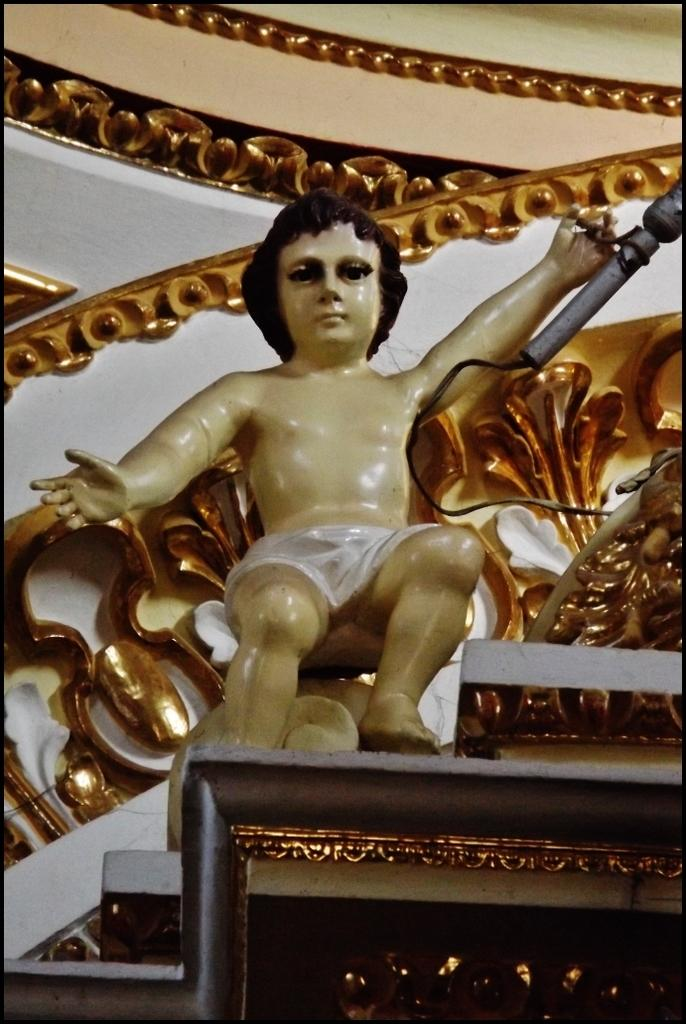What can be seen on the wall in the image? There is a sculpture on the wall in the image. What is located on the right side of the image? There is a cable and an iron object on the object on the right side of the image. What is at the top of the image? The top of the image features a well. What type of pleasure can be seen in the image? There is no indication of pleasure in the image; it features a sculpture, cable, iron object, and a well. How many arms are visible in the image? There are no arms visible in the image. 